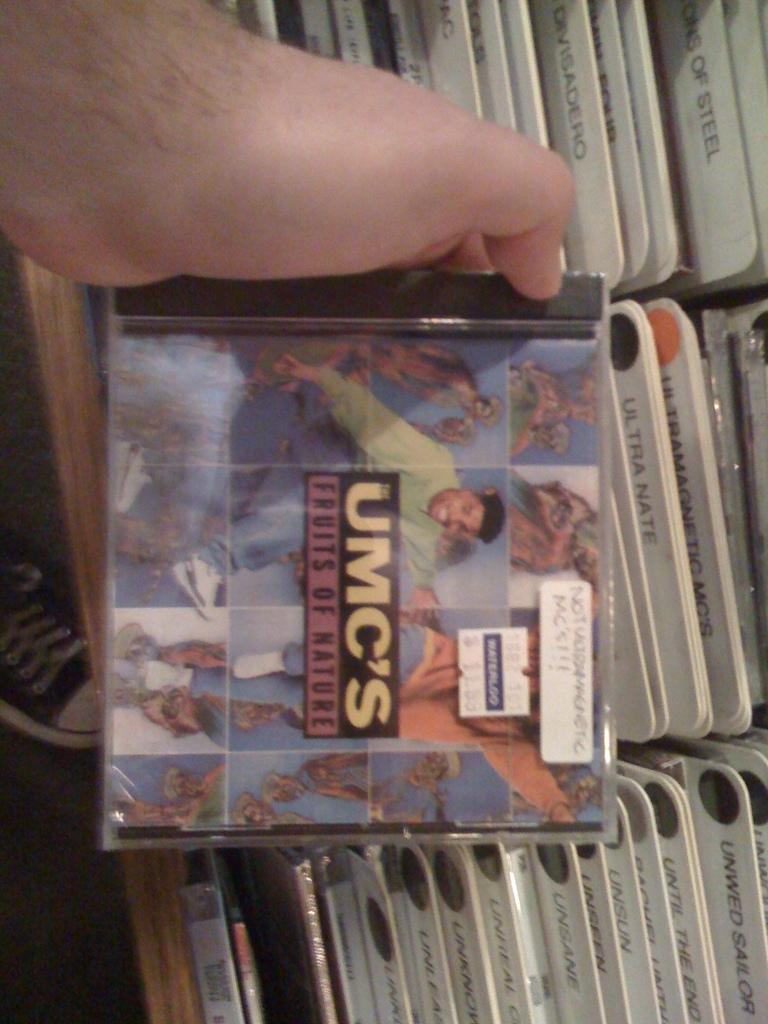What objects are visible in the image? There is a group of CDs in the image. Can you describe the position of the person's hand in the image? A person's hand is holding a CD in the top left of the image. What type of zephyr can be seen blowing through the CDs in the image? There is no zephyr present in the image; it is a group of CDs and a person's hand holding one of them. How many pies are visible in the image? There are no pies present in the image; it features a group of CDs and a person's hand holding one of them. 